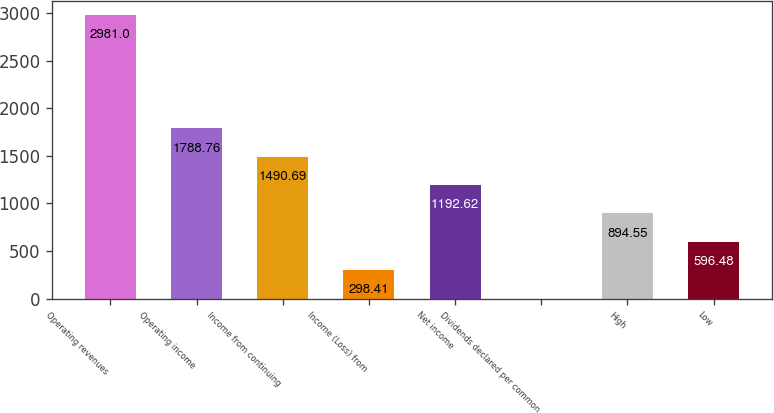<chart> <loc_0><loc_0><loc_500><loc_500><bar_chart><fcel>Operating revenues<fcel>Operating income<fcel>Income from continuing<fcel>Income (Loss) from<fcel>Net income<fcel>Dividends declared per common<fcel>High<fcel>Low<nl><fcel>2981<fcel>1788.76<fcel>1490.69<fcel>298.41<fcel>1192.62<fcel>0.34<fcel>894.55<fcel>596.48<nl></chart> 